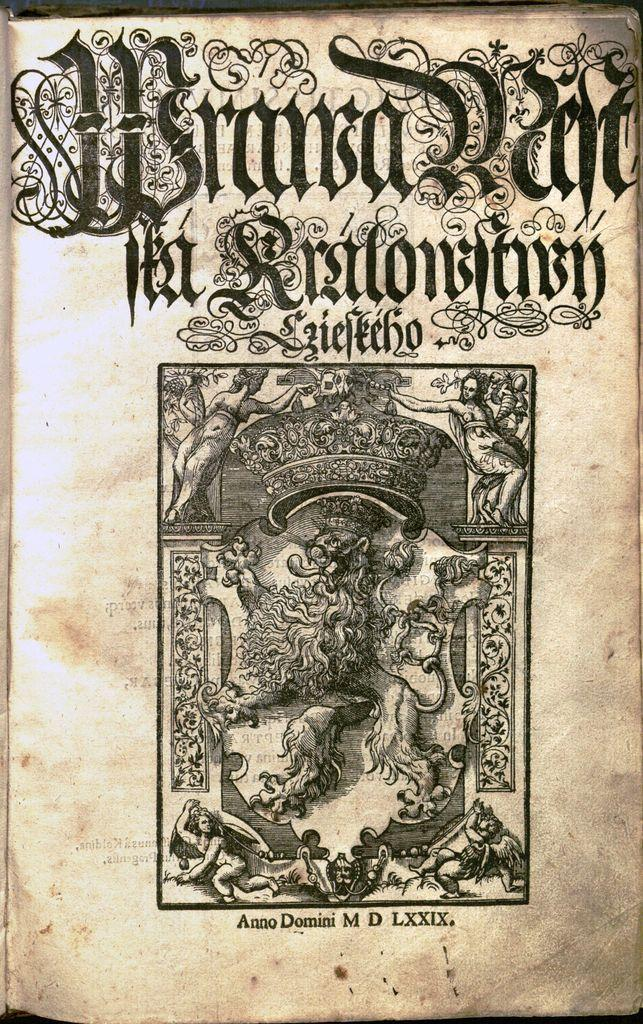<image>
Describe the image concisely. A book cover has the year in Roman numerals LXXIX at the bottom of the page. 